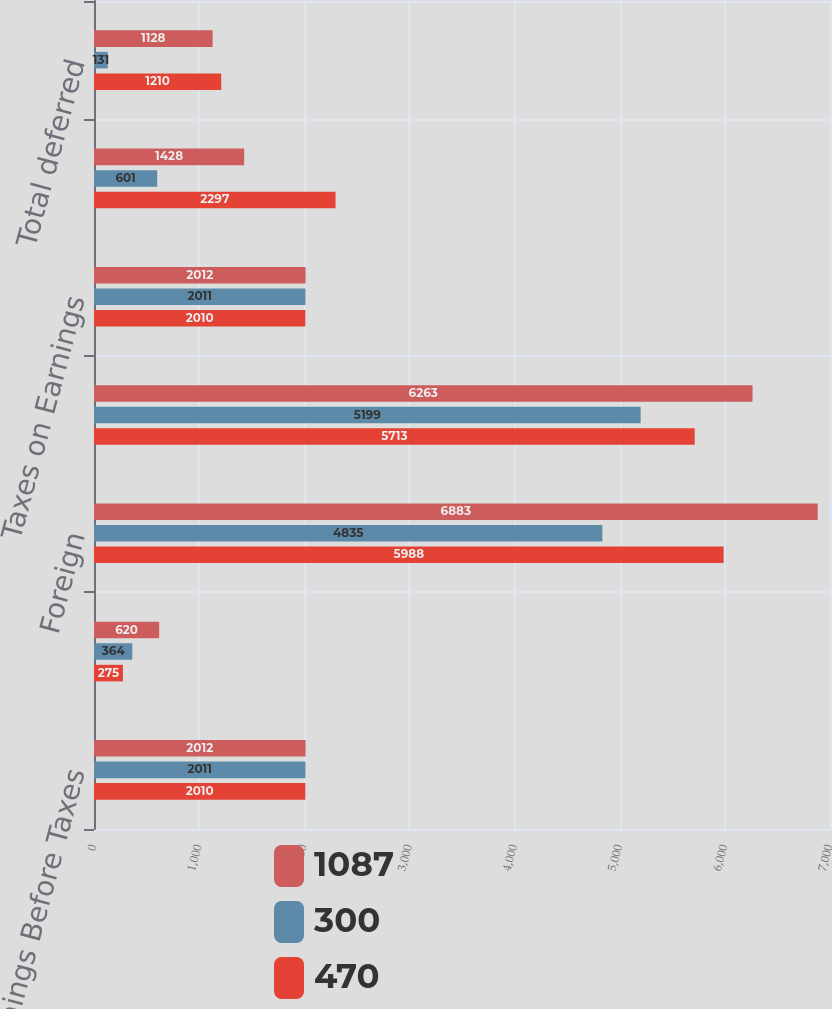<chart> <loc_0><loc_0><loc_500><loc_500><stacked_bar_chart><ecel><fcel>Earnings Before Taxes<fcel>Domestic<fcel>Foreign<fcel>Total<fcel>Taxes on Earnings<fcel>Total current<fcel>Total deferred<nl><fcel>1087<fcel>2012<fcel>620<fcel>6883<fcel>6263<fcel>2012<fcel>1428<fcel>1128<nl><fcel>300<fcel>2011<fcel>364<fcel>4835<fcel>5199<fcel>2011<fcel>601<fcel>131<nl><fcel>470<fcel>2010<fcel>275<fcel>5988<fcel>5713<fcel>2010<fcel>2297<fcel>1210<nl></chart> 